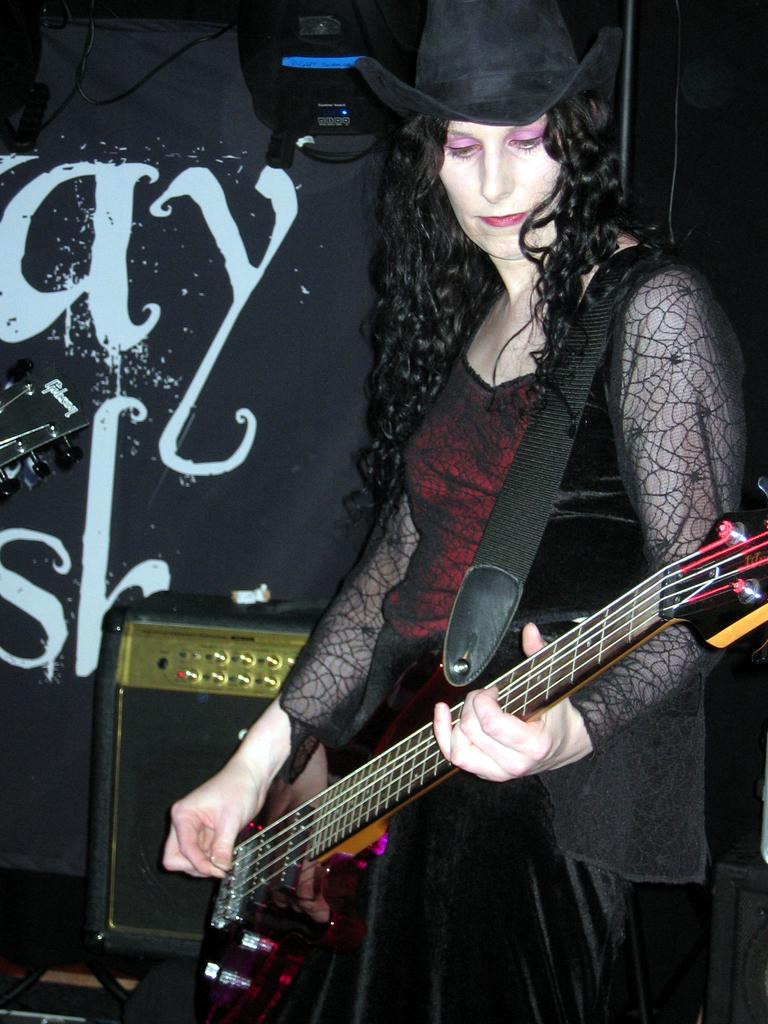Who is the main subject in the image? There is a woman in the image. Where is the woman positioned in the image? The woman is standing in the center. What is the woman holding in the image? The woman is holding a guitar. What is the woman doing with the guitar? The woman is playing the guitar. What type of brain can be seen in the image? There is no brain present in the image; it features a woman playing a guitar. In which bedroom is the woman playing the guitar? The image does not show a bedroom, nor does it provide any information about the location of the woman. 